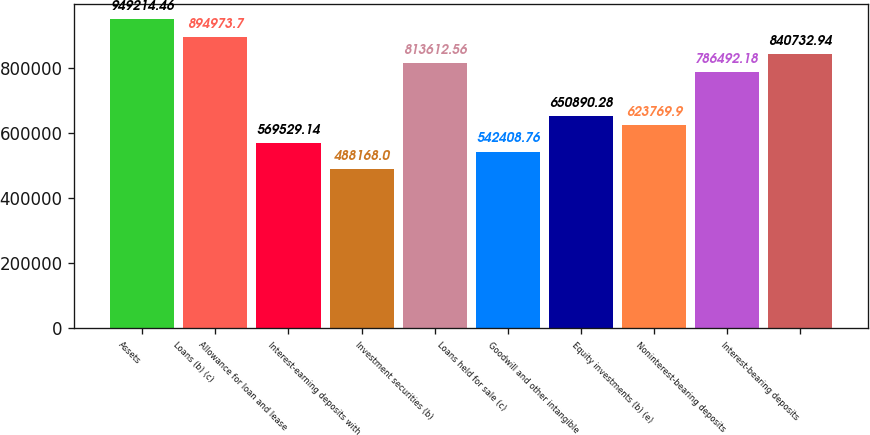Convert chart. <chart><loc_0><loc_0><loc_500><loc_500><bar_chart><fcel>Assets<fcel>Loans (b) (c)<fcel>Allowance for loan and lease<fcel>Interest-earning deposits with<fcel>Investment securities (b)<fcel>Loans held for sale (c)<fcel>Goodwill and other intangible<fcel>Equity investments (b) (e)<fcel>Noninterest-bearing deposits<fcel>Interest-bearing deposits<nl><fcel>949214<fcel>894974<fcel>569529<fcel>488168<fcel>813613<fcel>542409<fcel>650890<fcel>623770<fcel>786492<fcel>840733<nl></chart> 